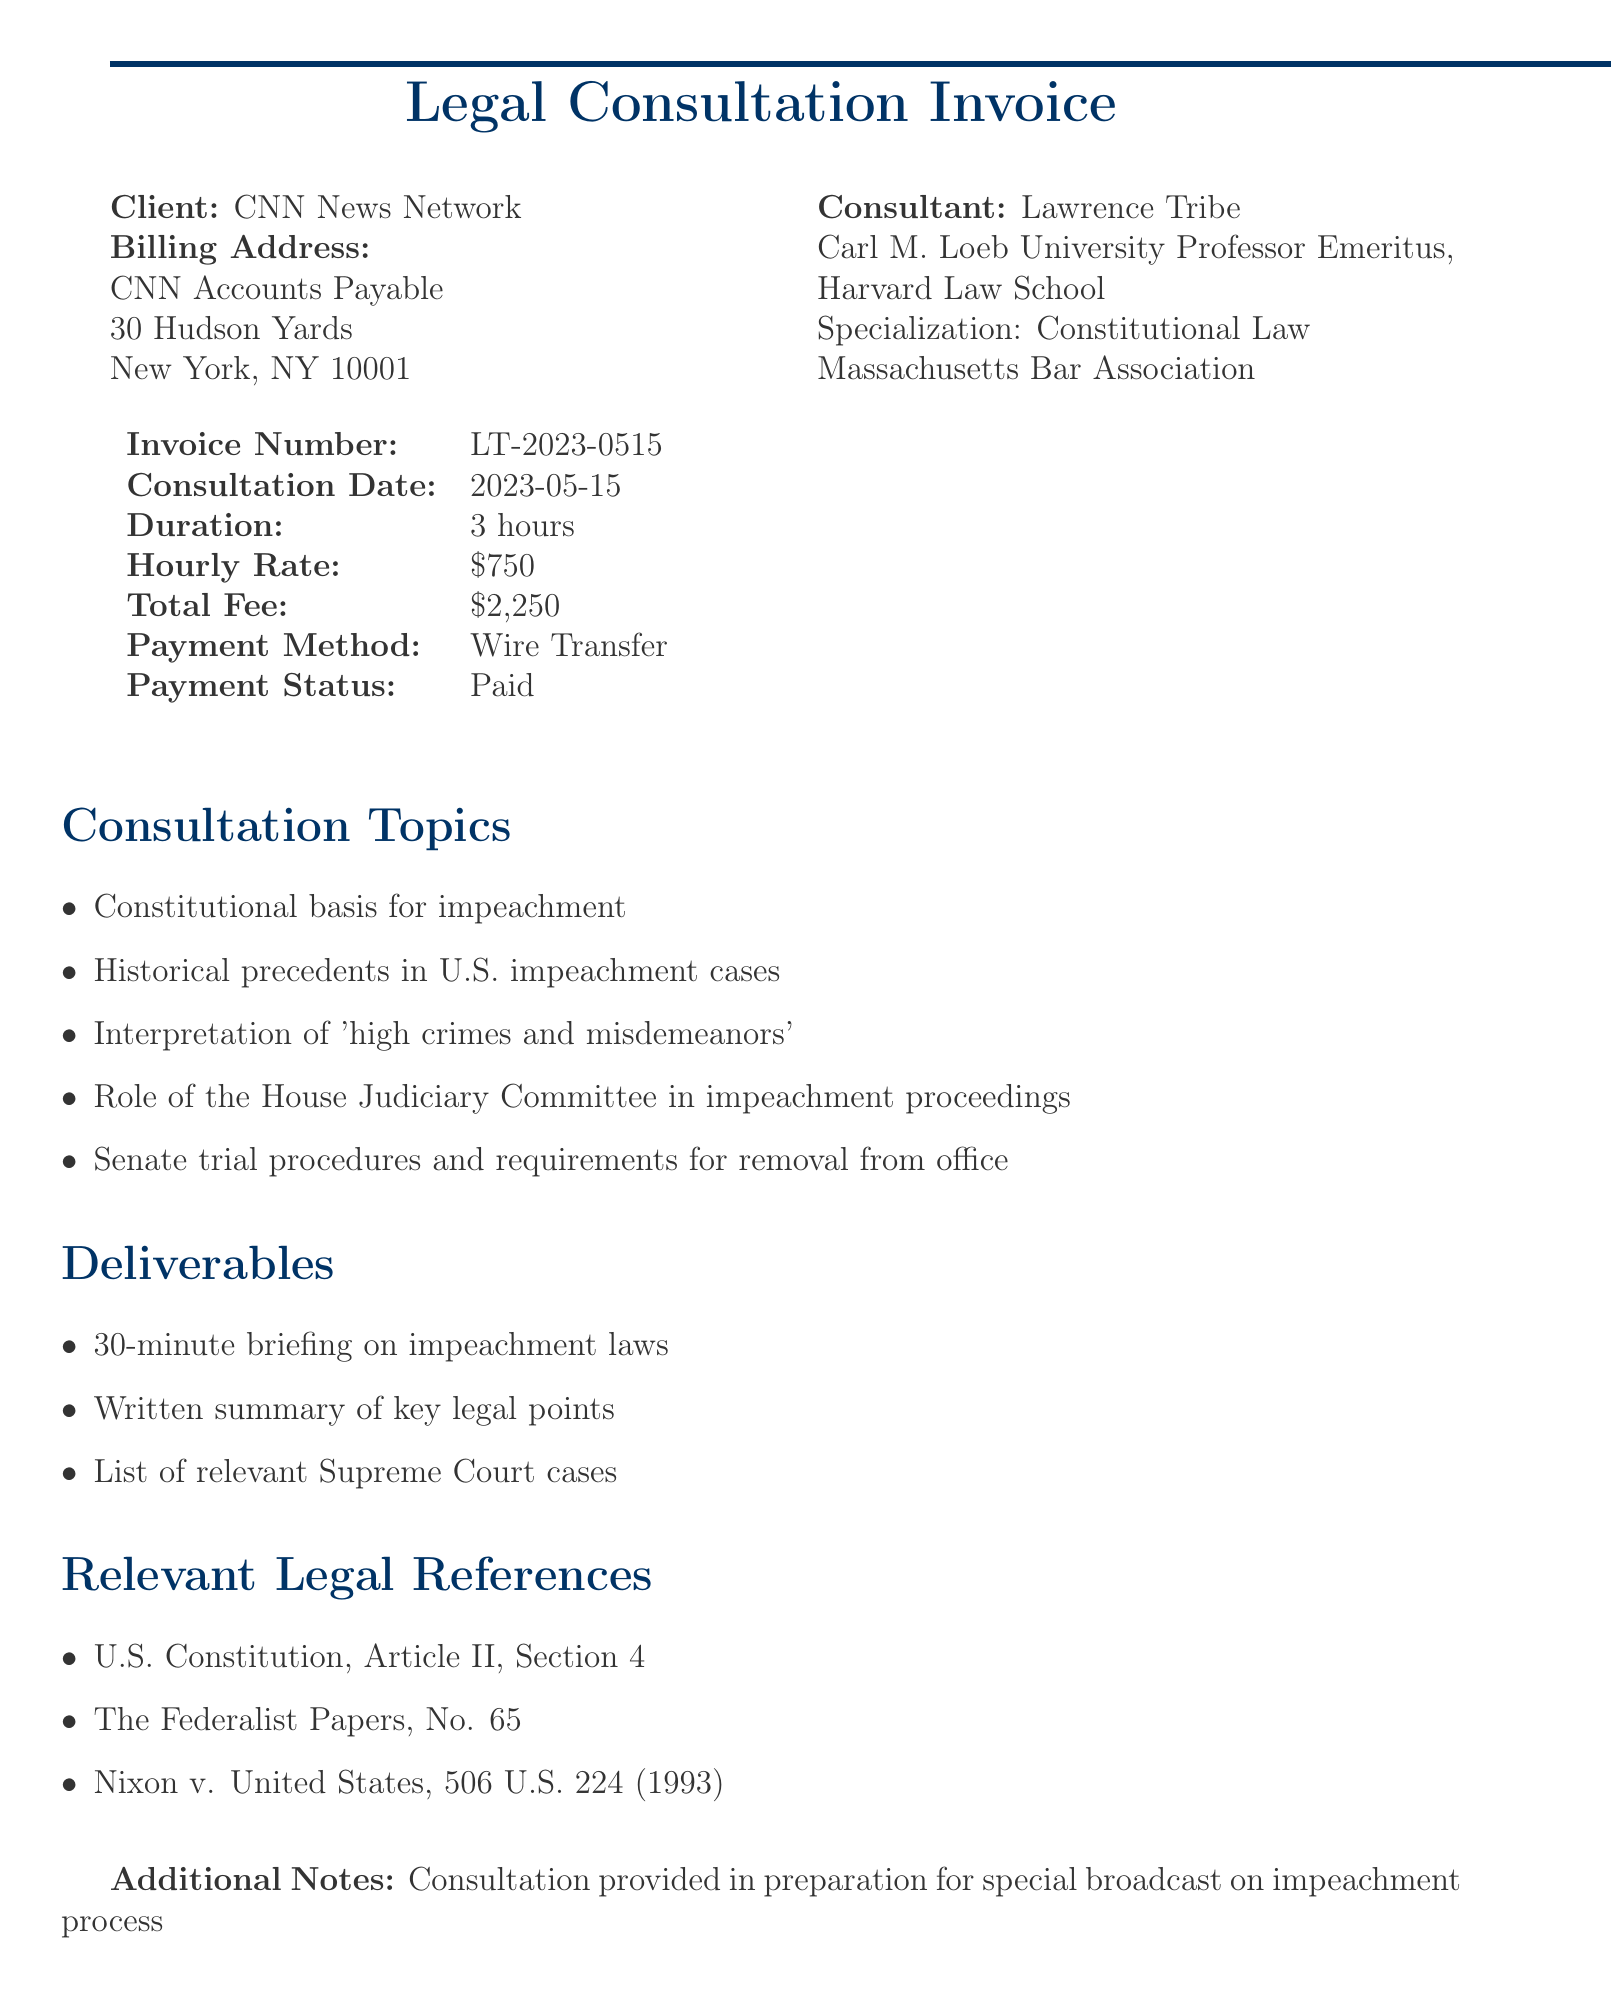What is the total fee for the consultation? The total fee is explicitly stated in the document as $2,250.
Answer: $2,250 Who is the client for the legal consultation? The client is identified at the beginning of the document as CNN News Network.
Answer: CNN News Network What is the date of the consultation? The consultation date is specified in the document as 2023-05-15.
Answer: 2023-05-15 How long did the consultation last? The duration of the consultation is indicated in the document as 3 hours.
Answer: 3 hours What topics were covered during the consultation? The document lists five topics related to impeachment that were discussed during the consultation.
Answer: Constitutional basis for impeachment, Historical precedents in U.S. impeachment cases, Interpretation of 'high crimes and misdemeanors', Role of the House Judiciary Committee in impeachment proceedings, Senate trial procedures and requirements for removal from office What method was used for payment? The payment method is recorded in the document as Wire Transfer.
Answer: Wire Transfer Who provided the consultation? The consultant's name, as stated in the document, is Lawrence Tribe.
Answer: Lawrence Tribe What deliverables were provided after the consultation? Three deliverables are listed in the document: a briefing, a summary, and a list of cases.
Answer: 30-minute briefing on impeachment laws, Written summary of key legal points, List of relevant Supreme Court cases What additional notes are mentioned regarding the consultation? The document contains a note stating that the consultation was for a special broadcast on the impeachment process.
Answer: Consultation provided in preparation for special broadcast on impeachment process 